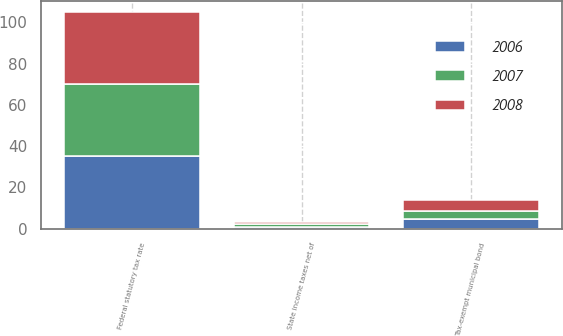Convert chart. <chart><loc_0><loc_0><loc_500><loc_500><stacked_bar_chart><ecel><fcel>Federal statutory tax rate<fcel>State income taxes net of<fcel>Tax-exempt municipal bond<nl><fcel>2007<fcel>35<fcel>1.7<fcel>4.1<nl><fcel>2008<fcel>35<fcel>0.7<fcel>5.2<nl><fcel>2006<fcel>35<fcel>0.8<fcel>4.5<nl></chart> 